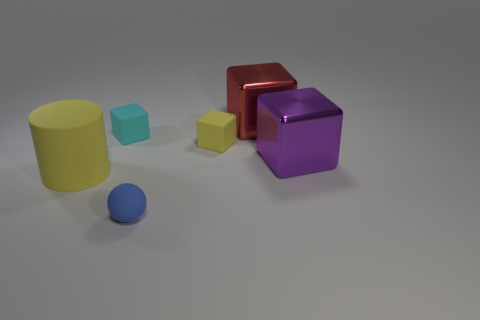What is the cyan block made of?
Offer a terse response. Rubber. There is a object that is the same color as the big rubber cylinder; what is its material?
Ensure brevity in your answer.  Rubber. There is a yellow matte thing behind the large matte thing; is its shape the same as the large purple thing?
Give a very brief answer. Yes. What number of things are either large yellow objects or tiny blue rubber objects?
Provide a succinct answer. 2. Is the material of the large cube behind the tiny yellow matte block the same as the blue thing?
Make the answer very short. No. The purple metallic block is what size?
Offer a terse response. Large. The small matte object that is the same color as the big cylinder is what shape?
Offer a very short reply. Cube. What number of blocks are either cyan things or big cyan shiny things?
Keep it short and to the point. 1. Is the number of big red shiny objects on the left side of the big matte cylinder the same as the number of large red shiny cubes left of the tiny cyan thing?
Provide a short and direct response. Yes. The yellow rubber thing that is the same shape as the large purple thing is what size?
Provide a succinct answer. Small. 